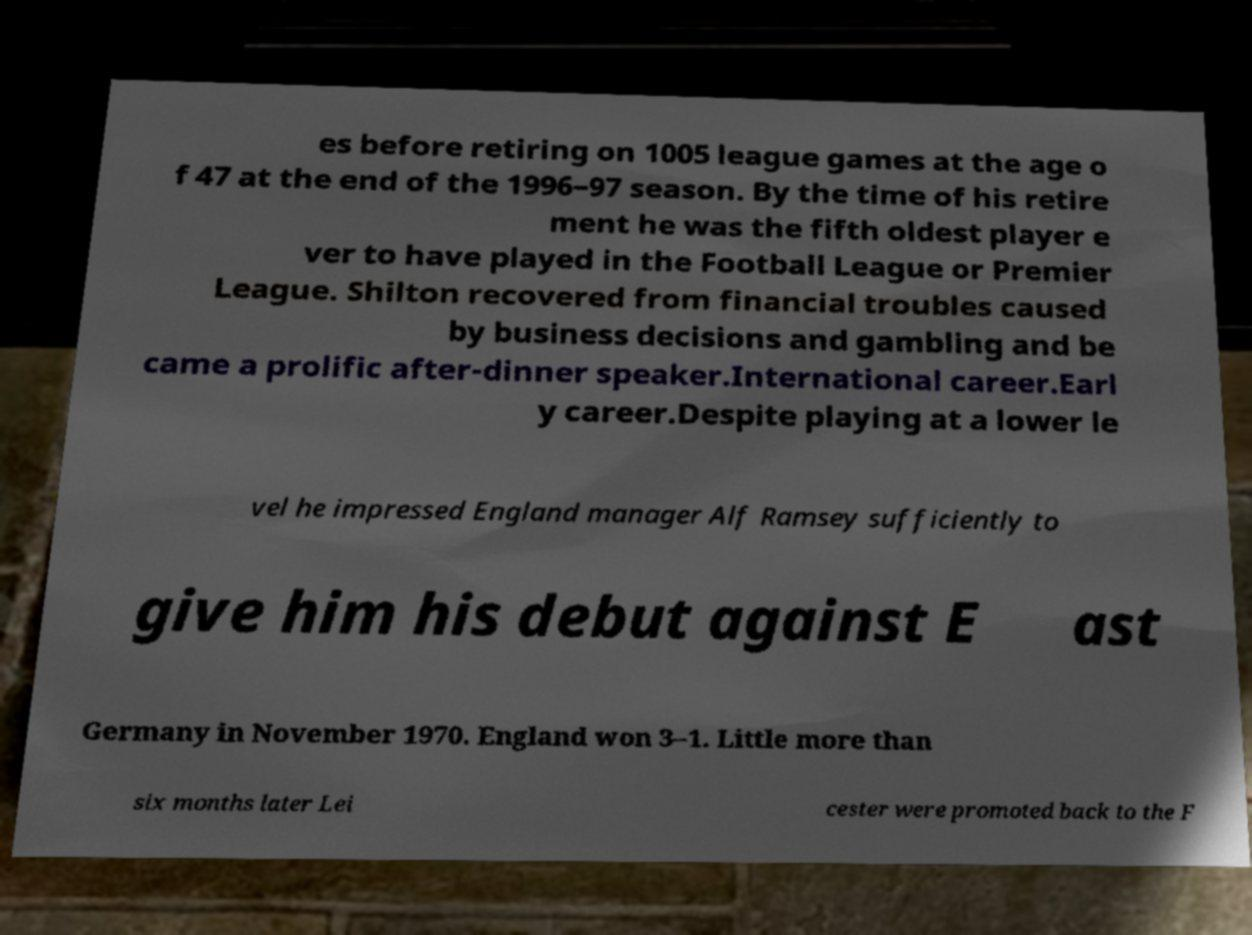Can you accurately transcribe the text from the provided image for me? es before retiring on 1005 league games at the age o f 47 at the end of the 1996–97 season. By the time of his retire ment he was the fifth oldest player e ver to have played in the Football League or Premier League. Shilton recovered from financial troubles caused by business decisions and gambling and be came a prolific after-dinner speaker.International career.Earl y career.Despite playing at a lower le vel he impressed England manager Alf Ramsey sufficiently to give him his debut against E ast Germany in November 1970. England won 3–1. Little more than six months later Lei cester were promoted back to the F 